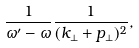Convert formula to latex. <formula><loc_0><loc_0><loc_500><loc_500>\frac { 1 } { \omega ^ { \prime } - \omega } \frac { 1 } { ( { k } _ { \perp } + { p } _ { \perp } ) ^ { 2 } } ,</formula> 